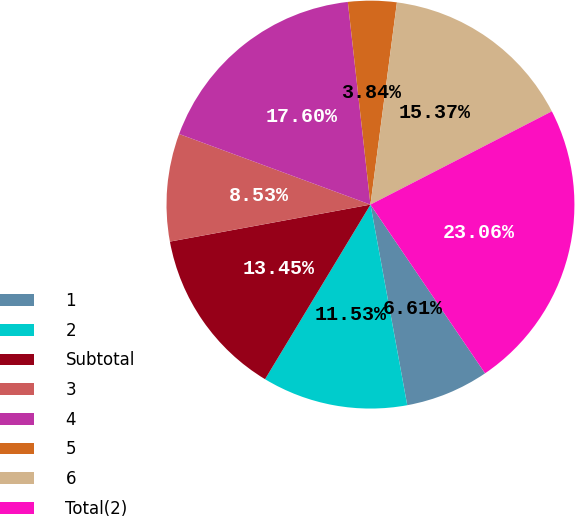<chart> <loc_0><loc_0><loc_500><loc_500><pie_chart><fcel>1<fcel>2<fcel>Subtotal<fcel>3<fcel>4<fcel>5<fcel>6<fcel>Total(2)<nl><fcel>6.61%<fcel>11.53%<fcel>13.45%<fcel>8.53%<fcel>17.6%<fcel>3.84%<fcel>15.37%<fcel>23.06%<nl></chart> 